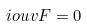Convert formula to latex. <formula><loc_0><loc_0><loc_500><loc_500>\L i o u v F = 0</formula> 